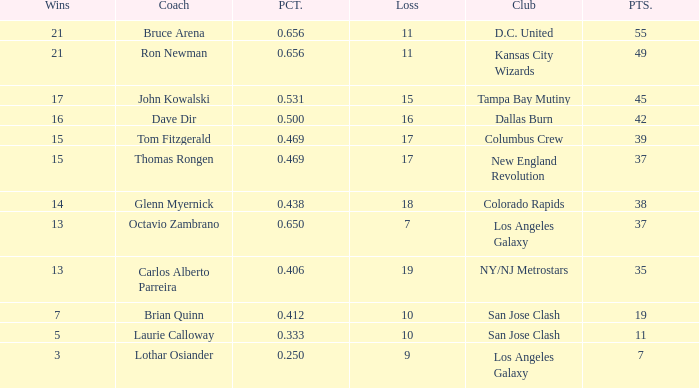What is the sum of points when Bruce Arena has 21 wins? 55.0. 